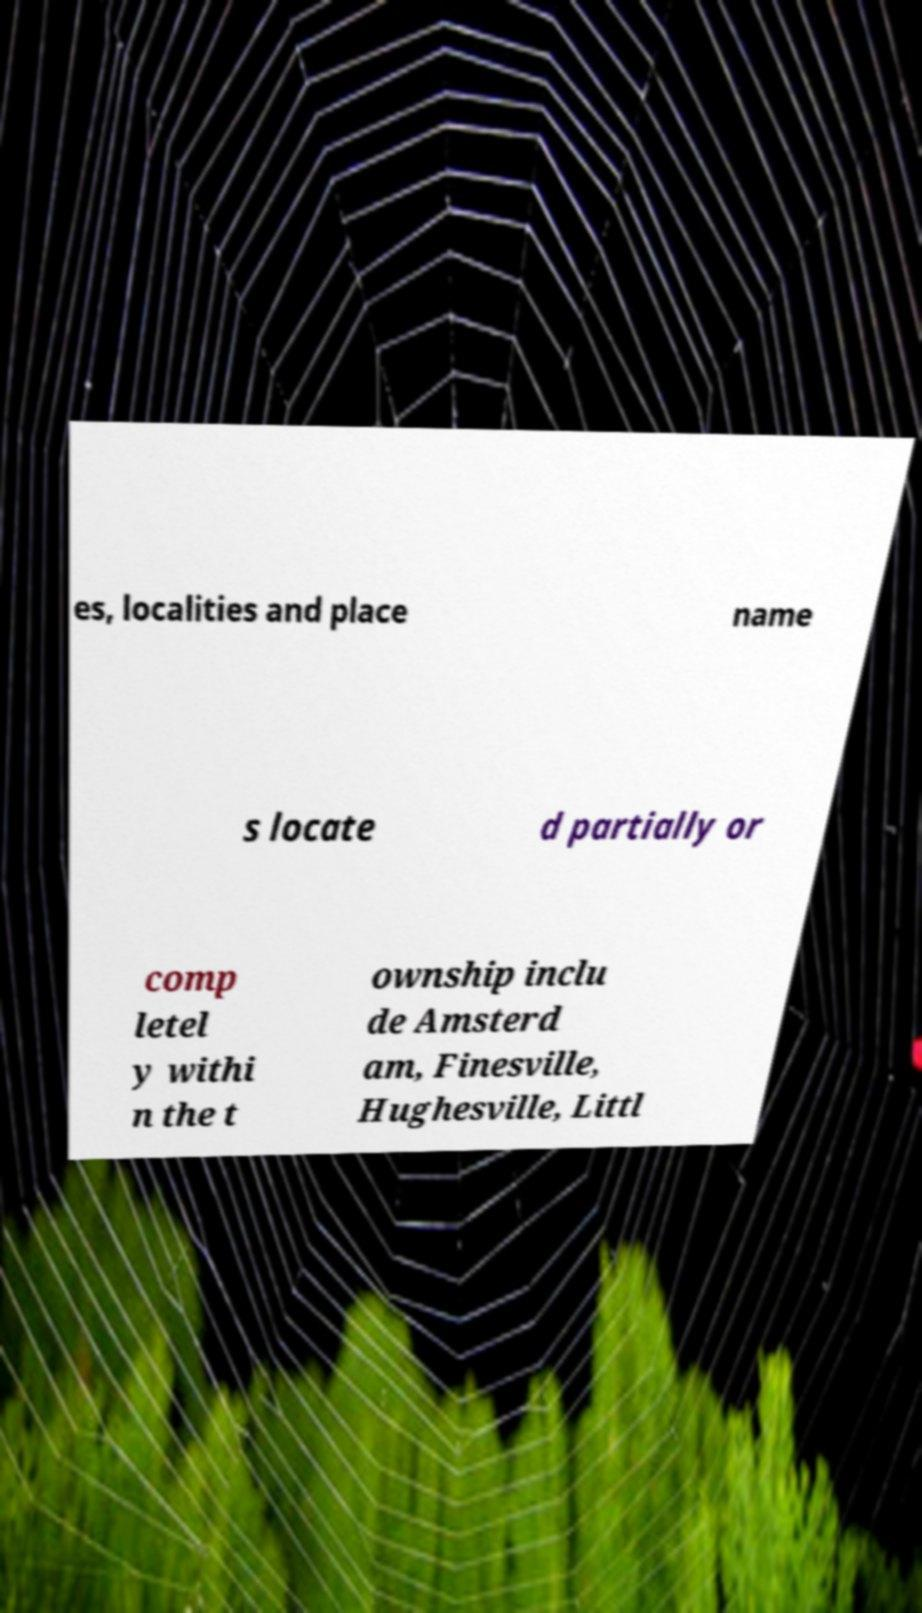Please read and relay the text visible in this image. What does it say? es, localities and place name s locate d partially or comp letel y withi n the t ownship inclu de Amsterd am, Finesville, Hughesville, Littl 